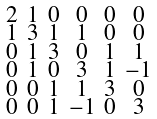Convert formula to latex. <formula><loc_0><loc_0><loc_500><loc_500>\begin{smallmatrix} 2 & 1 & 0 & 0 & 0 & 0 \\ 1 & 3 & 1 & 1 & 0 & 0 \\ 0 & 1 & 3 & 0 & 1 & 1 \\ 0 & 1 & 0 & 3 & 1 & - 1 \\ 0 & 0 & 1 & 1 & 3 & 0 \\ 0 & 0 & 1 & - 1 & 0 & 3 \end{smallmatrix}</formula> 